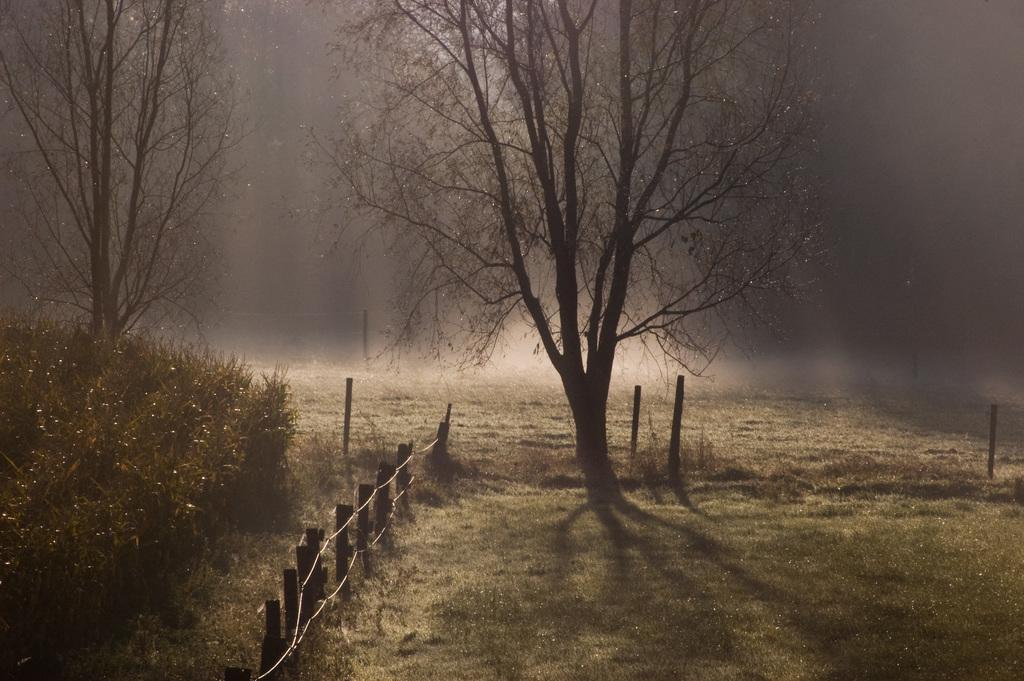How would you summarize this image in a sentence or two? In this picture I can see the plants and trees and in the middle of this picture I see the fencing and few poles and I see that it is a bit dark in the background. 